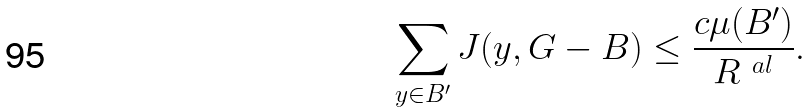Convert formula to latex. <formula><loc_0><loc_0><loc_500><loc_500>\sum _ { y \in B ^ { \prime } } J ( y , G - B ) \leq \frac { c \mu ( B ^ { \prime } ) } { R ^ { \ a l } } .</formula> 